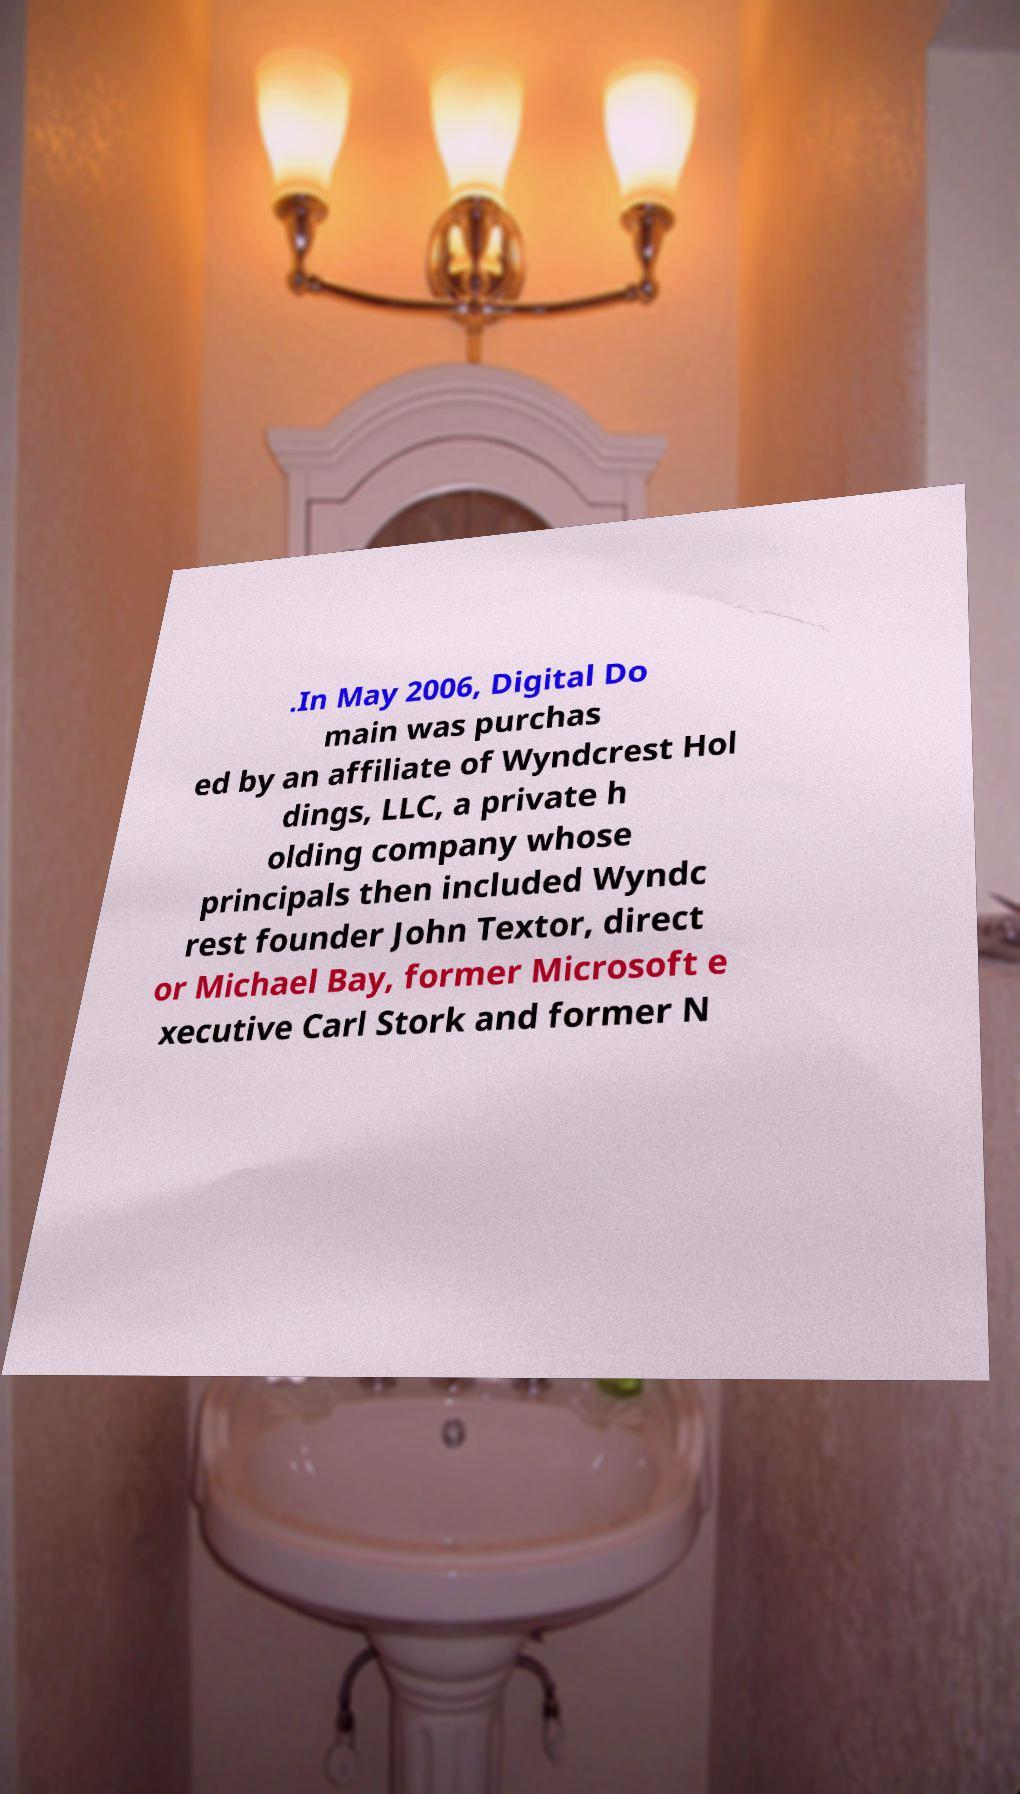Please read and relay the text visible in this image. What does it say? .In May 2006, Digital Do main was purchas ed by an affiliate of Wyndcrest Hol dings, LLC, a private h olding company whose principals then included Wyndc rest founder John Textor, direct or Michael Bay, former Microsoft e xecutive Carl Stork and former N 